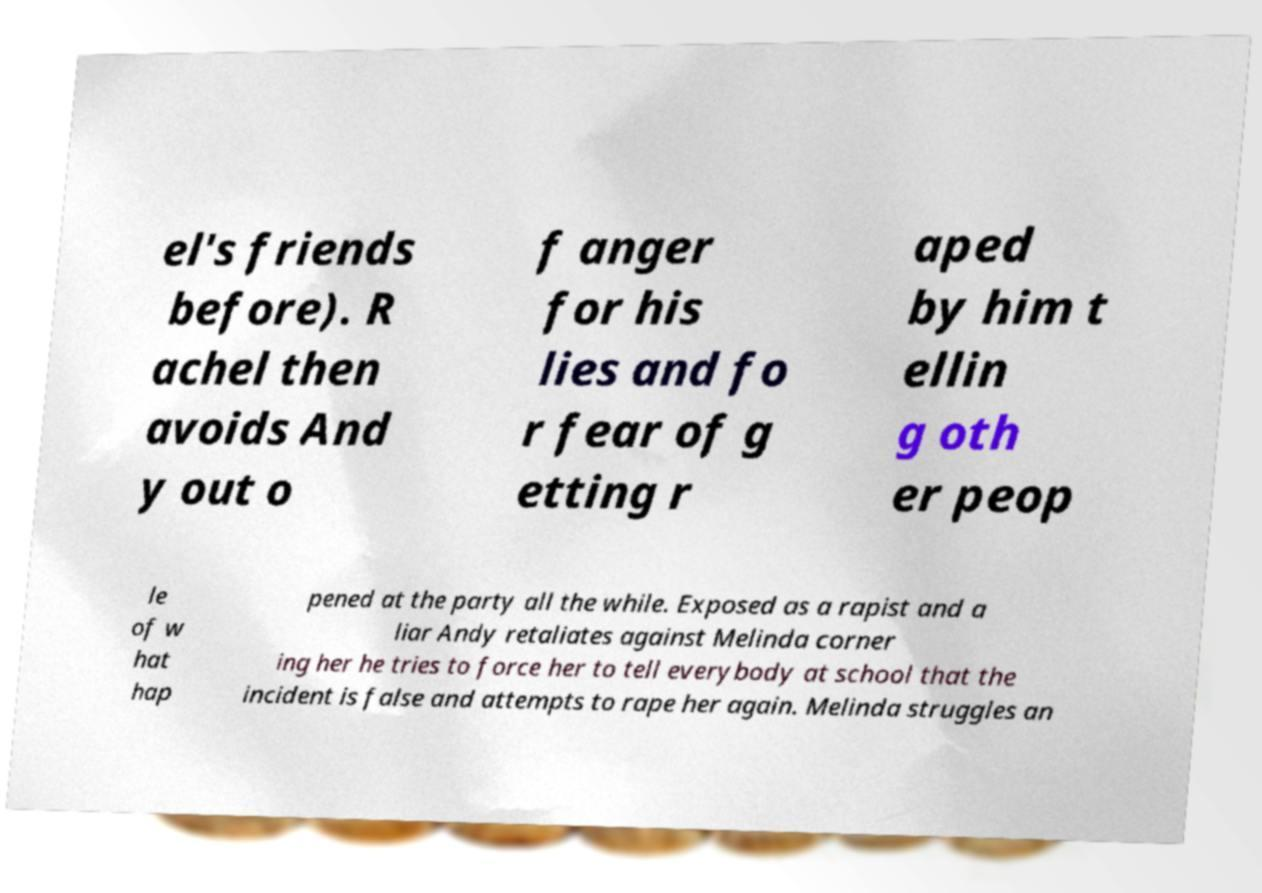Can you read and provide the text displayed in the image?This photo seems to have some interesting text. Can you extract and type it out for me? el's friends before). R achel then avoids And y out o f anger for his lies and fo r fear of g etting r aped by him t ellin g oth er peop le of w hat hap pened at the party all the while. Exposed as a rapist and a liar Andy retaliates against Melinda corner ing her he tries to force her to tell everybody at school that the incident is false and attempts to rape her again. Melinda struggles an 